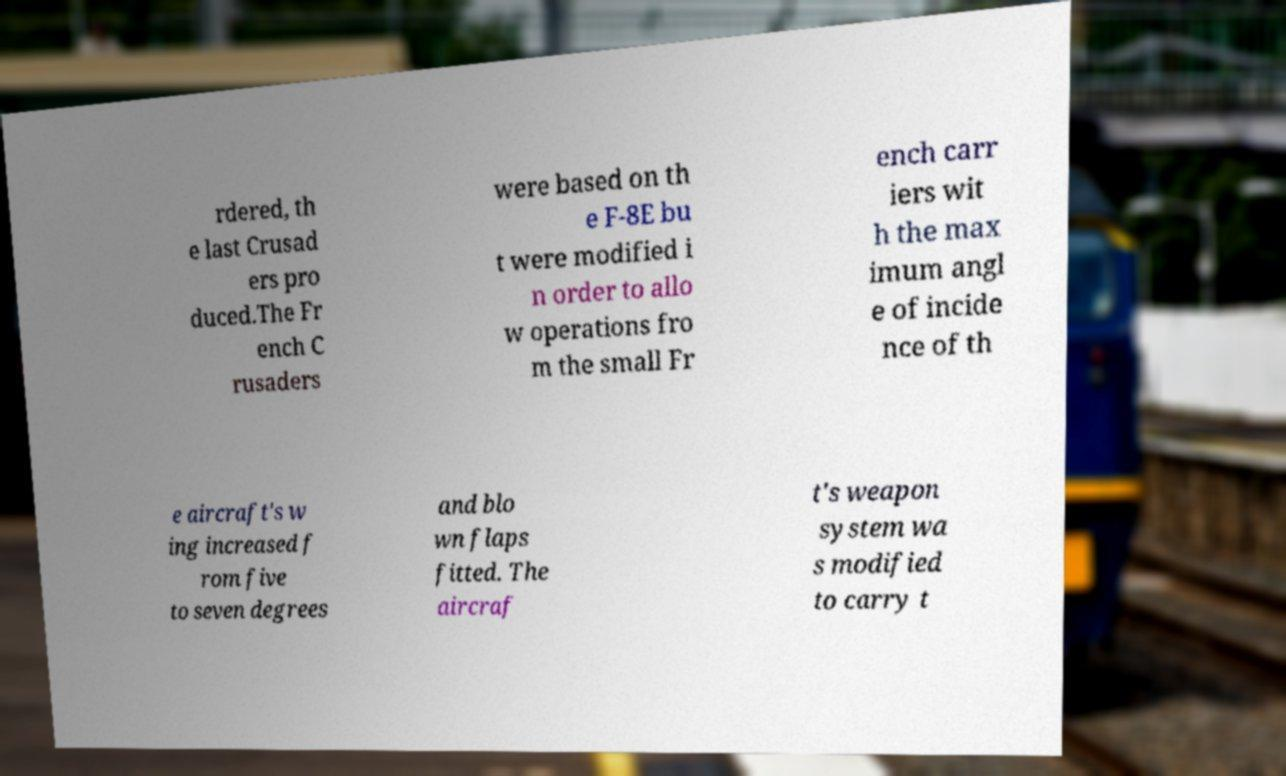What messages or text are displayed in this image? I need them in a readable, typed format. rdered, th e last Crusad ers pro duced.The Fr ench C rusaders were based on th e F-8E bu t were modified i n order to allo w operations fro m the small Fr ench carr iers wit h the max imum angl e of incide nce of th e aircraft's w ing increased f rom five to seven degrees and blo wn flaps fitted. The aircraf t's weapon system wa s modified to carry t 